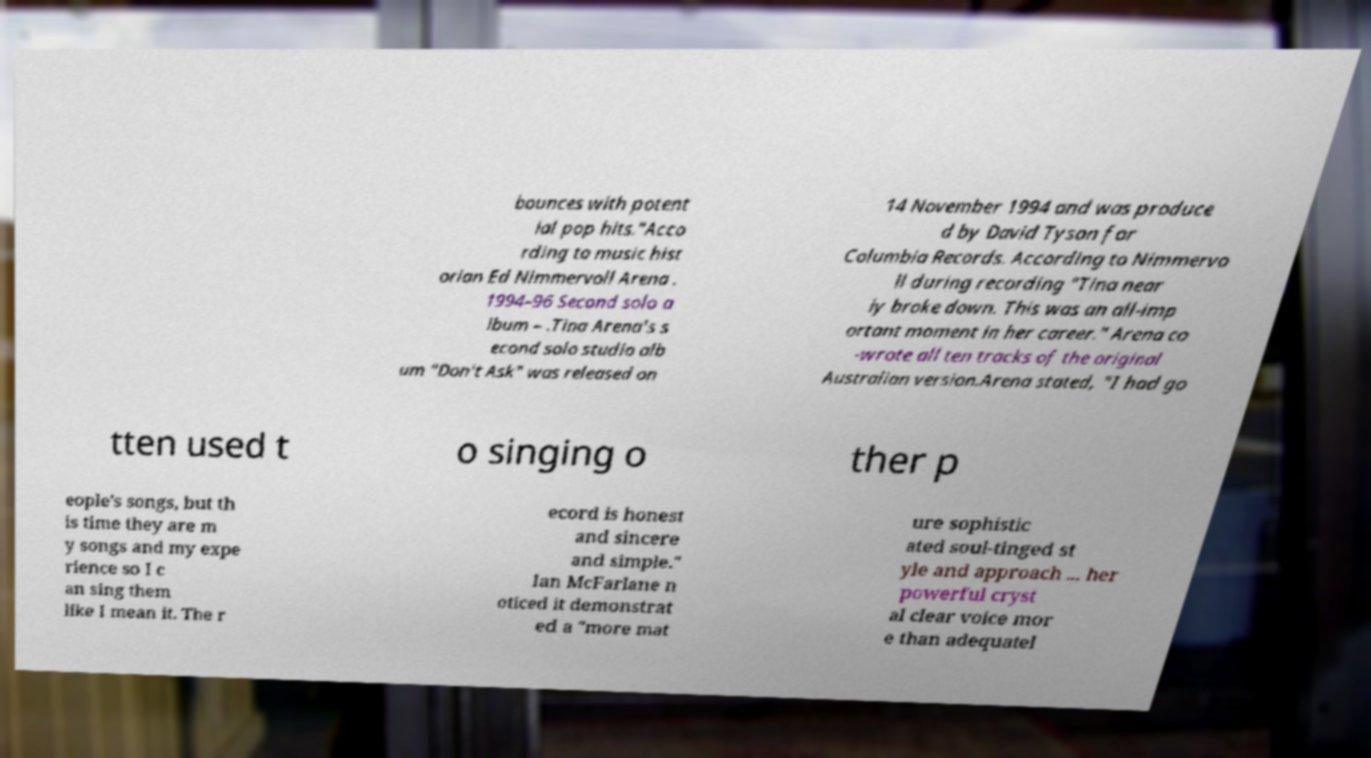Please identify and transcribe the text found in this image. bounces with potent ial pop hits."Acco rding to music hist orian Ed Nimmervoll Arena . 1994–96 Second solo a lbum – .Tina Arena's s econd solo studio alb um "Don't Ask" was released on 14 November 1994 and was produce d by David Tyson for Columbia Records. According to Nimmervo ll during recording "Tina near ly broke down. This was an all-imp ortant moment in her career." Arena co -wrote all ten tracks of the original Australian version.Arena stated, "I had go tten used t o singing o ther p eople's songs, but th is time they are m y songs and my expe rience so I c an sing them like I mean it. The r ecord is honest and sincere and simple." Ian McFarlane n oticed it demonstrat ed a "more mat ure sophistic ated soul-tinged st yle and approach ... her powerful cryst al clear voice mor e than adequatel 